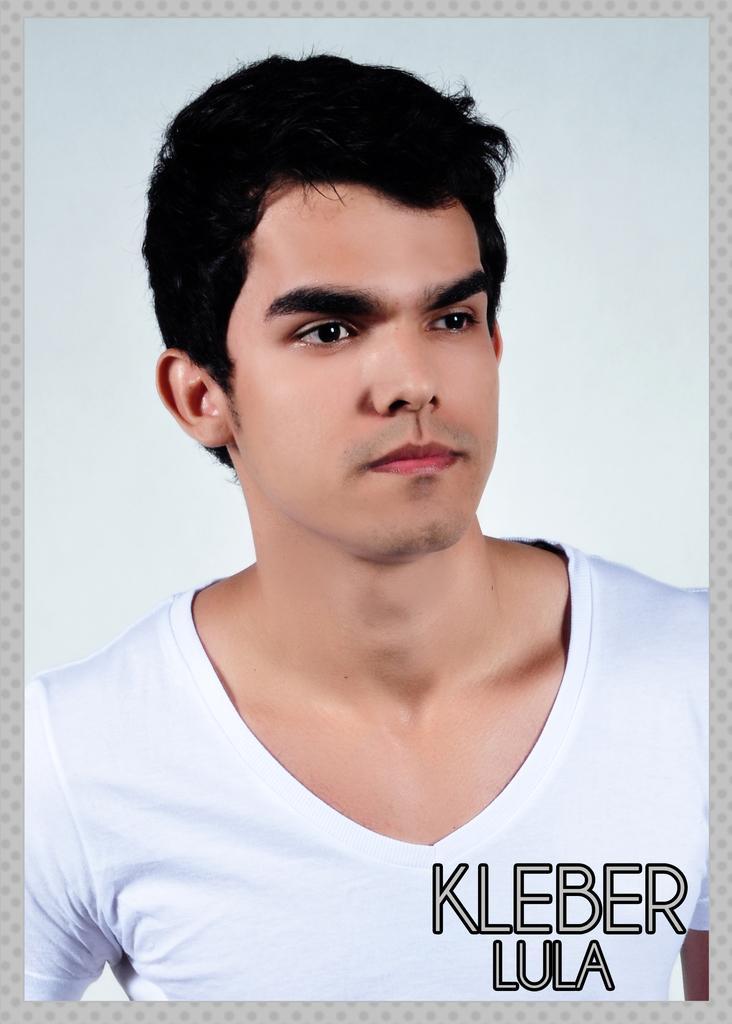Describe this image in one or two sentences. In this image I can see there is a photo of a person, who is wearing a t-shirt, on which there is a text, background is white. 